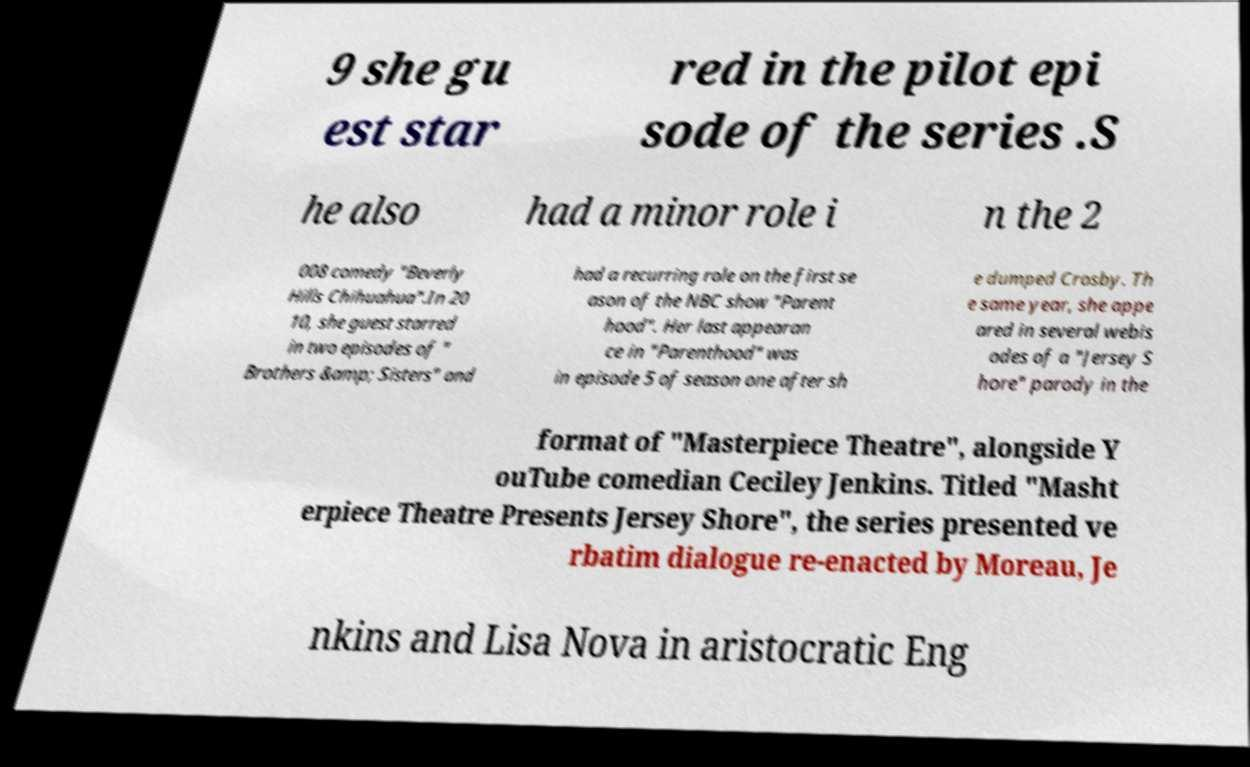I need the written content from this picture converted into text. Can you do that? 9 she gu est star red in the pilot epi sode of the series .S he also had a minor role i n the 2 008 comedy "Beverly Hills Chihuahua".In 20 10, she guest starred in two episodes of " Brothers &amp; Sisters" and had a recurring role on the first se ason of the NBC show "Parent hood". Her last appearan ce in "Parenthood" was in episode 5 of season one after sh e dumped Crosby. Th e same year, she appe ared in several webis odes of a "Jersey S hore" parody in the format of "Masterpiece Theatre", alongside Y ouTube comedian Ceciley Jenkins. Titled "Masht erpiece Theatre Presents Jersey Shore", the series presented ve rbatim dialogue re-enacted by Moreau, Je nkins and Lisa Nova in aristocratic Eng 